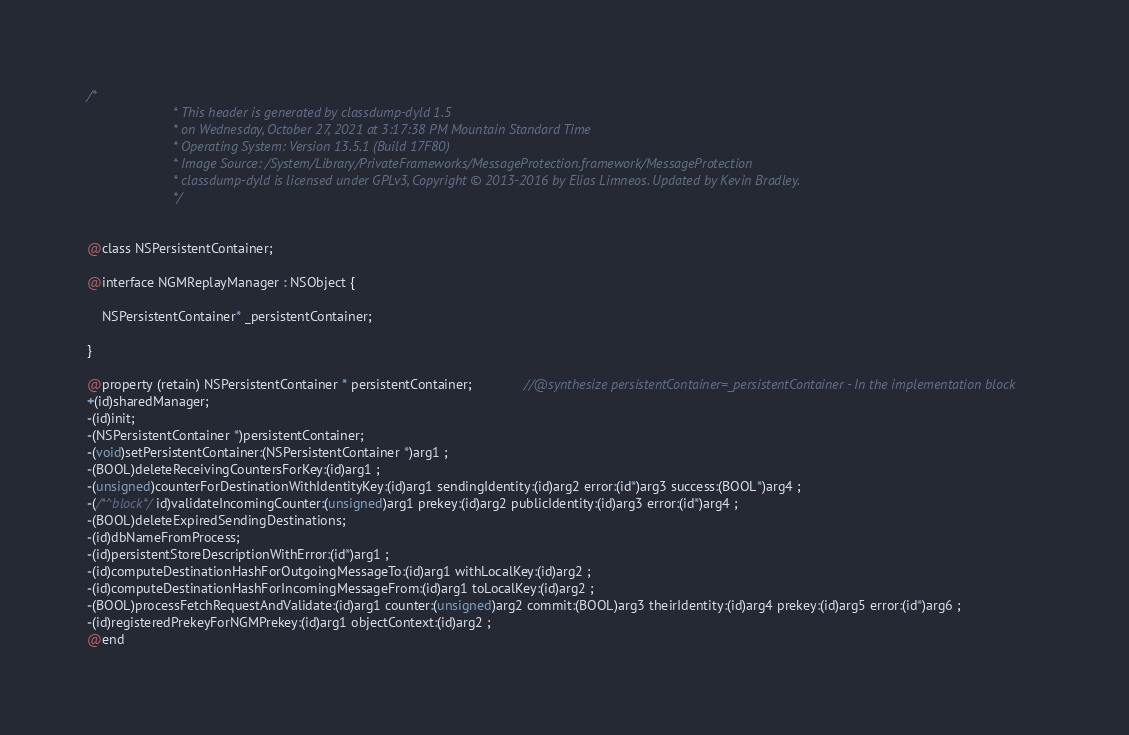<code> <loc_0><loc_0><loc_500><loc_500><_C_>/*
                       * This header is generated by classdump-dyld 1.5
                       * on Wednesday, October 27, 2021 at 3:17:38 PM Mountain Standard Time
                       * Operating System: Version 13.5.1 (Build 17F80)
                       * Image Source: /System/Library/PrivateFrameworks/MessageProtection.framework/MessageProtection
                       * classdump-dyld is licensed under GPLv3, Copyright © 2013-2016 by Elias Limneos. Updated by Kevin Bradley.
                       */


@class NSPersistentContainer;

@interface NGMReplayManager : NSObject {

	NSPersistentContainer* _persistentContainer;

}

@property (retain) NSPersistentContainer * persistentContainer;              //@synthesize persistentContainer=_persistentContainer - In the implementation block
+(id)sharedManager;
-(id)init;
-(NSPersistentContainer *)persistentContainer;
-(void)setPersistentContainer:(NSPersistentContainer *)arg1 ;
-(BOOL)deleteReceivingCountersForKey:(id)arg1 ;
-(unsigned)counterForDestinationWithIdentityKey:(id)arg1 sendingIdentity:(id)arg2 error:(id*)arg3 success:(BOOL*)arg4 ;
-(/*^block*/id)validateIncomingCounter:(unsigned)arg1 prekey:(id)arg2 publicIdentity:(id)arg3 error:(id*)arg4 ;
-(BOOL)deleteExpiredSendingDestinations;
-(id)dbNameFromProcess;
-(id)persistentStoreDescriptionWithError:(id*)arg1 ;
-(id)computeDestinationHashForOutgoingMessageTo:(id)arg1 withLocalKey:(id)arg2 ;
-(id)computeDestinationHashForIncomingMessageFrom:(id)arg1 toLocalKey:(id)arg2 ;
-(BOOL)processFetchRequestAndValidate:(id)arg1 counter:(unsigned)arg2 commit:(BOOL)arg3 theirIdentity:(id)arg4 prekey:(id)arg5 error:(id*)arg6 ;
-(id)registeredPrekeyForNGMPrekey:(id)arg1 objectContext:(id)arg2 ;
@end

</code> 